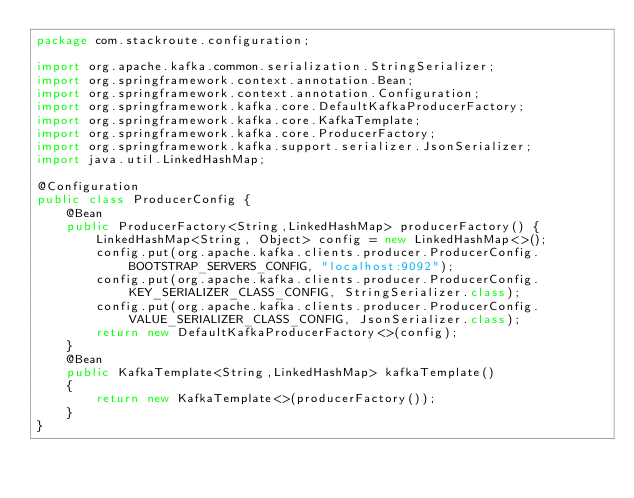<code> <loc_0><loc_0><loc_500><loc_500><_Java_>package com.stackroute.configuration;

import org.apache.kafka.common.serialization.StringSerializer;
import org.springframework.context.annotation.Bean;
import org.springframework.context.annotation.Configuration;
import org.springframework.kafka.core.DefaultKafkaProducerFactory;
import org.springframework.kafka.core.KafkaTemplate;
import org.springframework.kafka.core.ProducerFactory;
import org.springframework.kafka.support.serializer.JsonSerializer;
import java.util.LinkedHashMap;

@Configuration
public class ProducerConfig {
    @Bean
    public ProducerFactory<String,LinkedHashMap> producerFactory() {
        LinkedHashMap<String, Object> config = new LinkedHashMap<>();
        config.put(org.apache.kafka.clients.producer.ProducerConfig.BOOTSTRAP_SERVERS_CONFIG, "localhost:9092");
        config.put(org.apache.kafka.clients.producer.ProducerConfig.KEY_SERIALIZER_CLASS_CONFIG, StringSerializer.class);
        config.put(org.apache.kafka.clients.producer.ProducerConfig.VALUE_SERIALIZER_CLASS_CONFIG, JsonSerializer.class);
        return new DefaultKafkaProducerFactory<>(config);
    }
    @Bean
    public KafkaTemplate<String,LinkedHashMap> kafkaTemplate()
    {
        return new KafkaTemplate<>(producerFactory());
    }
}
</code> 